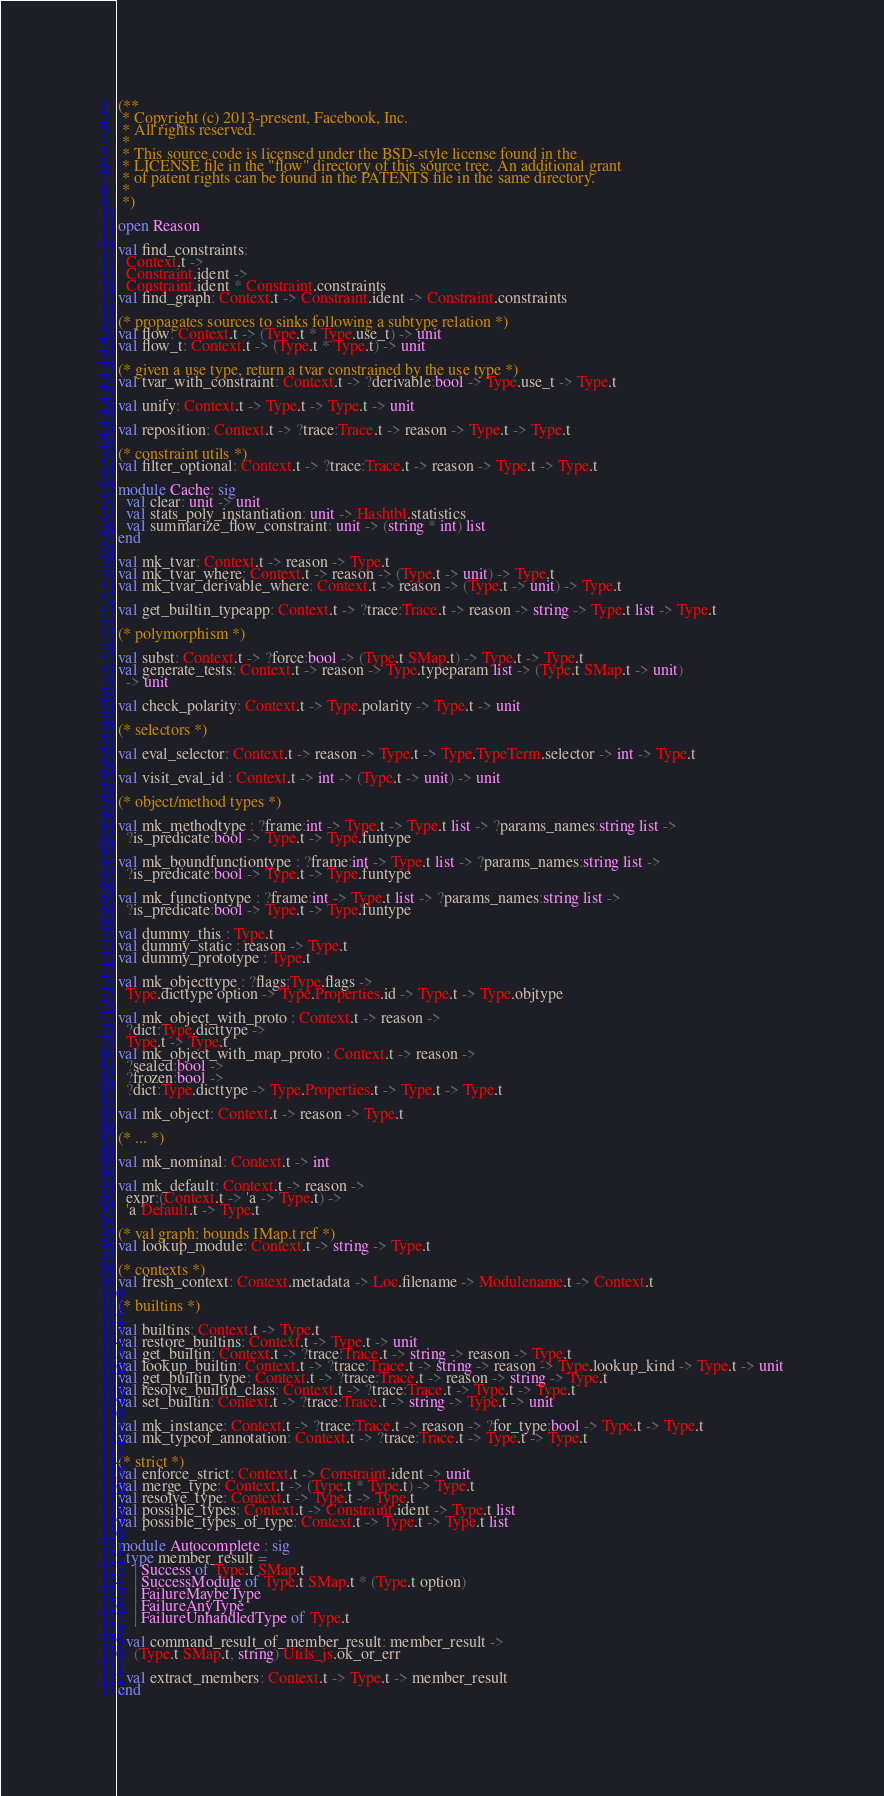<code> <loc_0><loc_0><loc_500><loc_500><_OCaml_>(**
 * Copyright (c) 2013-present, Facebook, Inc.
 * All rights reserved.
 *
 * This source code is licensed under the BSD-style license found in the
 * LICENSE file in the "flow" directory of this source tree. An additional grant
 * of patent rights can be found in the PATENTS file in the same directory.
 *
 *)

open Reason

val find_constraints:
  Context.t ->
  Constraint.ident ->
  Constraint.ident * Constraint.constraints
val find_graph: Context.t -> Constraint.ident -> Constraint.constraints

(* propagates sources to sinks following a subtype relation *)
val flow: Context.t -> (Type.t * Type.use_t) -> unit
val flow_t: Context.t -> (Type.t * Type.t) -> unit

(* given a use type, return a tvar constrained by the use type *)
val tvar_with_constraint: Context.t -> ?derivable:bool -> Type.use_t -> Type.t

val unify: Context.t -> Type.t -> Type.t -> unit

val reposition: Context.t -> ?trace:Trace.t -> reason -> Type.t -> Type.t

(* constraint utils *)
val filter_optional: Context.t -> ?trace:Trace.t -> reason -> Type.t -> Type.t

module Cache: sig
  val clear: unit -> unit
  val stats_poly_instantiation: unit -> Hashtbl.statistics
  val summarize_flow_constraint: unit -> (string * int) list
end

val mk_tvar: Context.t -> reason -> Type.t
val mk_tvar_where: Context.t -> reason -> (Type.t -> unit) -> Type.t
val mk_tvar_derivable_where: Context.t -> reason -> (Type.t -> unit) -> Type.t

val get_builtin_typeapp: Context.t -> ?trace:Trace.t -> reason -> string -> Type.t list -> Type.t

(* polymorphism *)

val subst: Context.t -> ?force:bool -> (Type.t SMap.t) -> Type.t -> Type.t
val generate_tests: Context.t -> reason -> Type.typeparam list -> (Type.t SMap.t -> unit)
  -> unit

val check_polarity: Context.t -> Type.polarity -> Type.t -> unit

(* selectors *)

val eval_selector: Context.t -> reason -> Type.t -> Type.TypeTerm.selector -> int -> Type.t

val visit_eval_id : Context.t -> int -> (Type.t -> unit) -> unit

(* object/method types *)

val mk_methodtype : ?frame:int -> Type.t -> Type.t list -> ?params_names:string list ->
  ?is_predicate:bool -> Type.t -> Type.funtype

val mk_boundfunctiontype : ?frame:int -> Type.t list -> ?params_names:string list ->
  ?is_predicate:bool -> Type.t -> Type.funtype

val mk_functiontype : ?frame:int -> Type.t list -> ?params_names:string list ->
  ?is_predicate:bool -> Type.t -> Type.funtype

val dummy_this : Type.t
val dummy_static : reason -> Type.t
val dummy_prototype : Type.t

val mk_objecttype : ?flags:Type.flags ->
  Type.dicttype option -> Type.Properties.id -> Type.t -> Type.objtype

val mk_object_with_proto : Context.t -> reason ->
  ?dict:Type.dicttype ->
  Type.t -> Type.t
val mk_object_with_map_proto : Context.t -> reason ->
  ?sealed:bool ->
  ?frozen:bool ->
  ?dict:Type.dicttype -> Type.Properties.t -> Type.t -> Type.t

val mk_object: Context.t -> reason -> Type.t

(* ... *)

val mk_nominal: Context.t -> int

val mk_default: Context.t -> reason ->
  expr:(Context.t -> 'a -> Type.t) ->
  'a Default.t -> Type.t

(* val graph: bounds IMap.t ref *)
val lookup_module: Context.t -> string -> Type.t

(* contexts *)
val fresh_context: Context.metadata -> Loc.filename -> Modulename.t -> Context.t

(* builtins *)

val builtins: Context.t -> Type.t
val restore_builtins: Context.t -> Type.t -> unit
val get_builtin: Context.t -> ?trace:Trace.t -> string -> reason -> Type.t
val lookup_builtin: Context.t -> ?trace:Trace.t -> string -> reason -> Type.lookup_kind -> Type.t -> unit
val get_builtin_type: Context.t -> ?trace:Trace.t -> reason -> string -> Type.t
val resolve_builtin_class: Context.t -> ?trace:Trace.t -> Type.t -> Type.t
val set_builtin: Context.t -> ?trace:Trace.t -> string -> Type.t -> unit

val mk_instance: Context.t -> ?trace:Trace.t -> reason -> ?for_type:bool -> Type.t -> Type.t
val mk_typeof_annotation: Context.t -> ?trace:Trace.t -> Type.t -> Type.t

(* strict *)
val enforce_strict: Context.t -> Constraint.ident -> unit
val merge_type: Context.t -> (Type.t * Type.t) -> Type.t
val resolve_type: Context.t -> Type.t -> Type.t
val possible_types: Context.t -> Constraint.ident -> Type.t list
val possible_types_of_type: Context.t -> Type.t -> Type.t list

module Autocomplete : sig
  type member_result =
    | Success of Type.t SMap.t
    | SuccessModule of Type.t SMap.t * (Type.t option)
    | FailureMaybeType
    | FailureAnyType
    | FailureUnhandledType of Type.t

  val command_result_of_member_result: member_result ->
    (Type.t SMap.t, string) Utils_js.ok_or_err

  val extract_members: Context.t -> Type.t -> member_result
end
</code> 